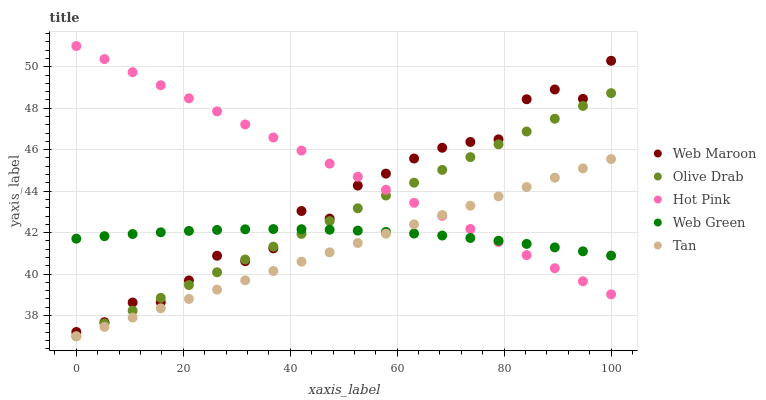Does Tan have the minimum area under the curve?
Answer yes or no. Yes. Does Hot Pink have the maximum area under the curve?
Answer yes or no. Yes. Does Web Maroon have the minimum area under the curve?
Answer yes or no. No. Does Web Maroon have the maximum area under the curve?
Answer yes or no. No. Is Hot Pink the smoothest?
Answer yes or no. Yes. Is Web Maroon the roughest?
Answer yes or no. Yes. Is Web Maroon the smoothest?
Answer yes or no. No. Is Hot Pink the roughest?
Answer yes or no. No. Does Tan have the lowest value?
Answer yes or no. Yes. Does Hot Pink have the lowest value?
Answer yes or no. No. Does Hot Pink have the highest value?
Answer yes or no. Yes. Does Web Maroon have the highest value?
Answer yes or no. No. Is Tan less than Web Maroon?
Answer yes or no. Yes. Is Web Maroon greater than Tan?
Answer yes or no. Yes. Does Hot Pink intersect Tan?
Answer yes or no. Yes. Is Hot Pink less than Tan?
Answer yes or no. No. Is Hot Pink greater than Tan?
Answer yes or no. No. Does Tan intersect Web Maroon?
Answer yes or no. No. 